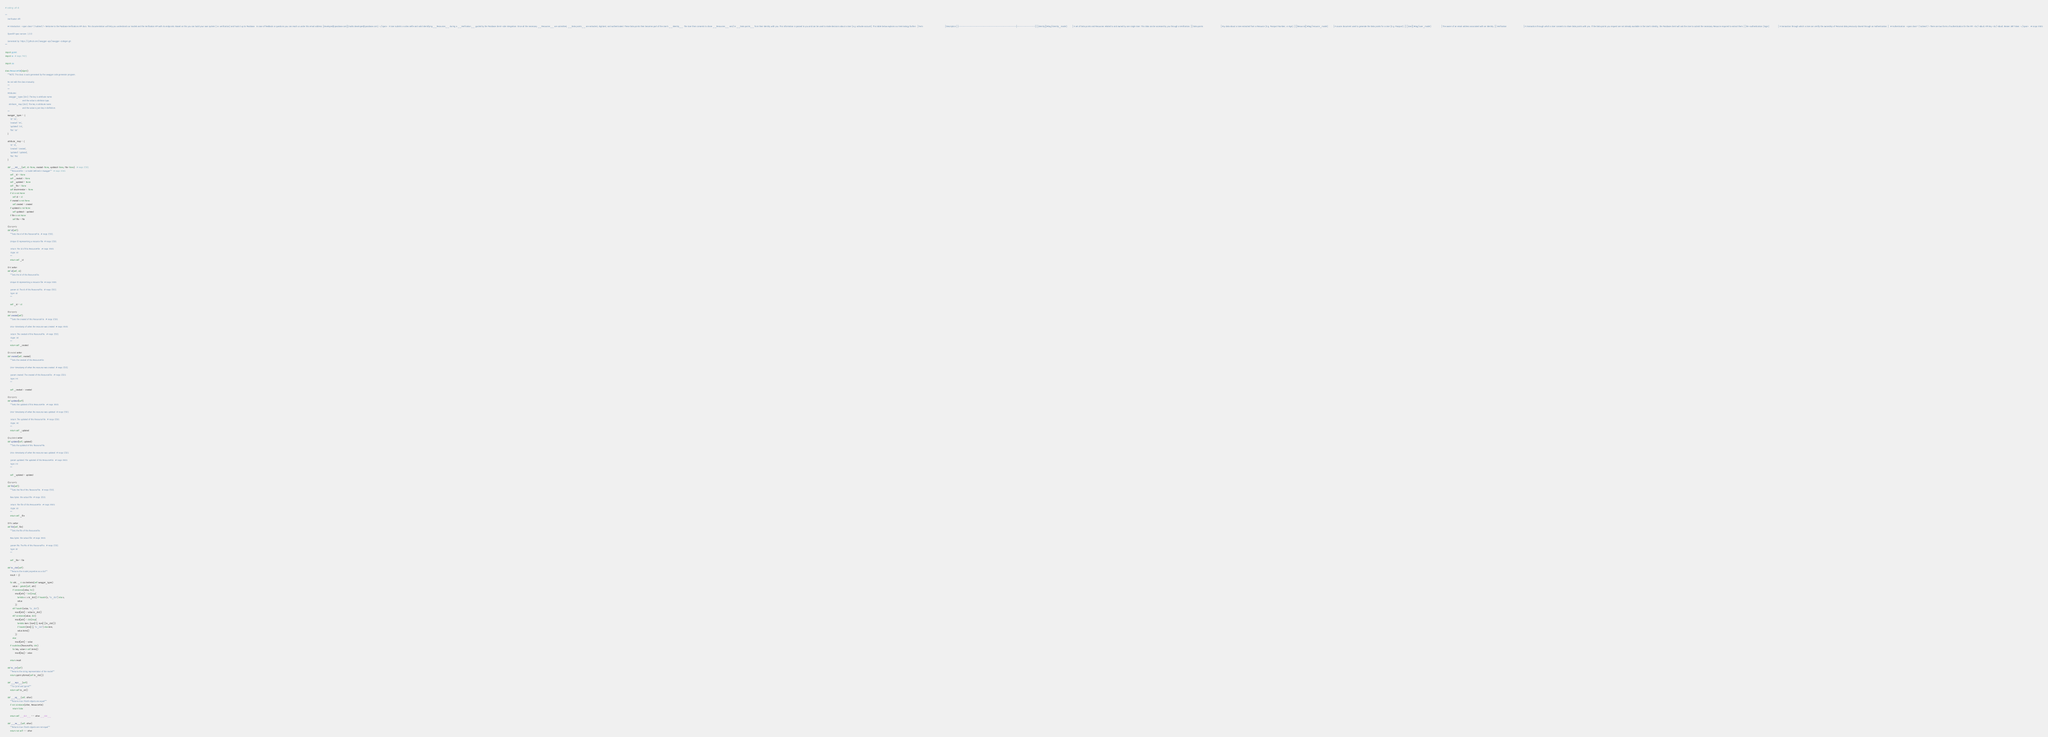<code> <loc_0><loc_0><loc_500><loc_500><_Python_># coding: utf-8

"""
    Verification API

    # Introduction  <span class=\"subtext\"> Welcome to the Passbase Verifications API docs. This documentation will help you understand our models and the Verification API with its endpoints. Based on this you can build your own system (i.e. verification) and hook it up to Passbase.  In case of feedback or questions you can reach us under this email address: [developer@passbase.com](mailto:developer@passbase.com). </span>  A User submits a video selfie and valid identifying __Resources__ during a __Verification__ guided by the Passbase client-side integration. Once all the necessary __Resources__ are submitted, __Data points__ are extracted, digitized, and authenticated. These Data points then becomes part of the User's __Identity__. The User then consents to share __Resources__ and/or __Data points__ from their Identity with you. This information is passed to you and can be used to make decisions about a User (e.g. activate account). This table below explains our terminology further.  | Term                                    | Description | |-----------------------------------------|-------------| | [Identity](#tag/identity_model)         | A set of Data points and Resources related to and owned by one single User. This data can be accessed by you through a Verification. | | Data points                             | Any data about a User extracted from a Resource (E.g. Passport Number, or Age). | | [Resource](#tag/resource_model)         | A source document used to generate the Data points for a User (E.g. Passport). | | [User](#tag/user_model)                 | The owner of an email address associated with an Identity. | | Verification                            | A transaction through which a User consents to share Data points with you. If the Data points you request are not already available in the User's Identity, the Passbase client will ask the User to submit the necessary Resource required to extract them. | | Re-authentication (login)               | A transaction through which a User can certify the ownership of Personal data previously shared through an Authentication. |   # Authentication  <span class=\"subtext\"> There are two forms of authentication for the API: <br/>&bull; API Key <br/>&bull; Bearer JWT Token  </span>   # noqa: E501

    OpenAPI spec version: 1.0.0
    
    Generated by: https://github.com/swagger-api/swagger-codegen.git
"""

import pprint
import re  # noqa: F401

import six

class ResourceFile(object):
    """NOTE: This class is auto generated by the swagger code generator program.

    Do not edit the class manually.
    """
    """
    Attributes:
      swagger_types (dict): The key is attribute name
                            and the value is attribute type.
      attribute_map (dict): The key is attribute name
                            and the value is json key in definition.
    """
    swagger_types = {
        'id': 'str',
        'created': 'int',
        'updated': 'int',
        'file': 'str'
    }

    attribute_map = {
        'id': 'id',
        'created': 'created',
        'updated': 'updated',
        'file': 'file'
    }

    def __init__(self, id=None, created=None, updated=None, file=None):  # noqa: E501
        """ResourceFile - a model defined in Swagger"""  # noqa: E501
        self._id = None
        self._created = None
        self._updated = None
        self._file = None
        self.discriminator = None
        if id is not None:
            self.id = id
        if created is not None:
            self.created = created
        if updated is not None:
            self.updated = updated
        if file is not None:
            self.file = file

    @property
    def id(self):
        """Gets the id of this ResourceFile.  # noqa: E501

        Unique ID representing a resource file  # noqa: E501

        :return: The id of this ResourceFile.  # noqa: E501
        :rtype: str
        """
        return self._id

    @id.setter
    def id(self, id):
        """Sets the id of this ResourceFile.

        Unique ID representing a resource file  # noqa: E501

        :param id: The id of this ResourceFile.  # noqa: E501
        :type: str
        """

        self._id = id

    @property
    def created(self):
        """Gets the created of this ResourceFile.  # noqa: E501

        Unix-timestamp of when the resource was created  # noqa: E501

        :return: The created of this ResourceFile.  # noqa: E501
        :rtype: int
        """
        return self._created

    @created.setter
    def created(self, created):
        """Sets the created of this ResourceFile.

        Unix-timestamp of when the resource was created  # noqa: E501

        :param created: The created of this ResourceFile.  # noqa: E501
        :type: int
        """

        self._created = created

    @property
    def updated(self):
        """Gets the updated of this ResourceFile.  # noqa: E501

        Unix-timestamp of when the resource was updated  # noqa: E501

        :return: The updated of this ResourceFile.  # noqa: E501
        :rtype: int
        """
        return self._updated

    @updated.setter
    def updated(self, updated):
        """Sets the updated of this ResourceFile.

        Unix-timestamp of when the resource was updated  # noqa: E501

        :param updated: The updated of this ResourceFile.  # noqa: E501
        :type: int
        """

        self._updated = updated

    @property
    def file(self):
        """Gets the file of this ResourceFile.  # noqa: E501

        Raw bytes: the actual file  # noqa: E501

        :return: The file of this ResourceFile.  # noqa: E501
        :rtype: str
        """
        return self._file

    @file.setter
    def file(self, file):
        """Sets the file of this ResourceFile.

        Raw bytes: the actual file  # noqa: E501

        :param file: The file of this ResourceFile.  # noqa: E501
        :type: str
        """

        self._file = file

    def to_dict(self):
        """Returns the model properties as a dict"""
        result = {}

        for attr, _ in six.iteritems(self.swagger_types):
            value = getattr(self, attr)
            if isinstance(value, list):
                result[attr] = list(map(
                    lambda x: x.to_dict() if hasattr(x, "to_dict") else x,
                    value
                ))
            elif hasattr(value, "to_dict"):
                result[attr] = value.to_dict()
            elif isinstance(value, dict):
                result[attr] = dict(map(
                    lambda item: (item[0], item[1].to_dict())
                    if hasattr(item[1], "to_dict") else item,
                    value.items()
                ))
            else:
                result[attr] = value
        if issubclass(ResourceFile, dict):
            for key, value in self.items():
                result[key] = value

        return result

    def to_str(self):
        """Returns the string representation of the model"""
        return pprint.pformat(self.to_dict())

    def __repr__(self):
        """For `print` and `pprint`"""
        return self.to_str()

    def __eq__(self, other):
        """Returns true if both objects are equal"""
        if not isinstance(other, ResourceFile):
            return False

        return self.__dict__ == other.__dict__

    def __ne__(self, other):
        """Returns true if both objects are not equal"""
        return not self == other
</code> 